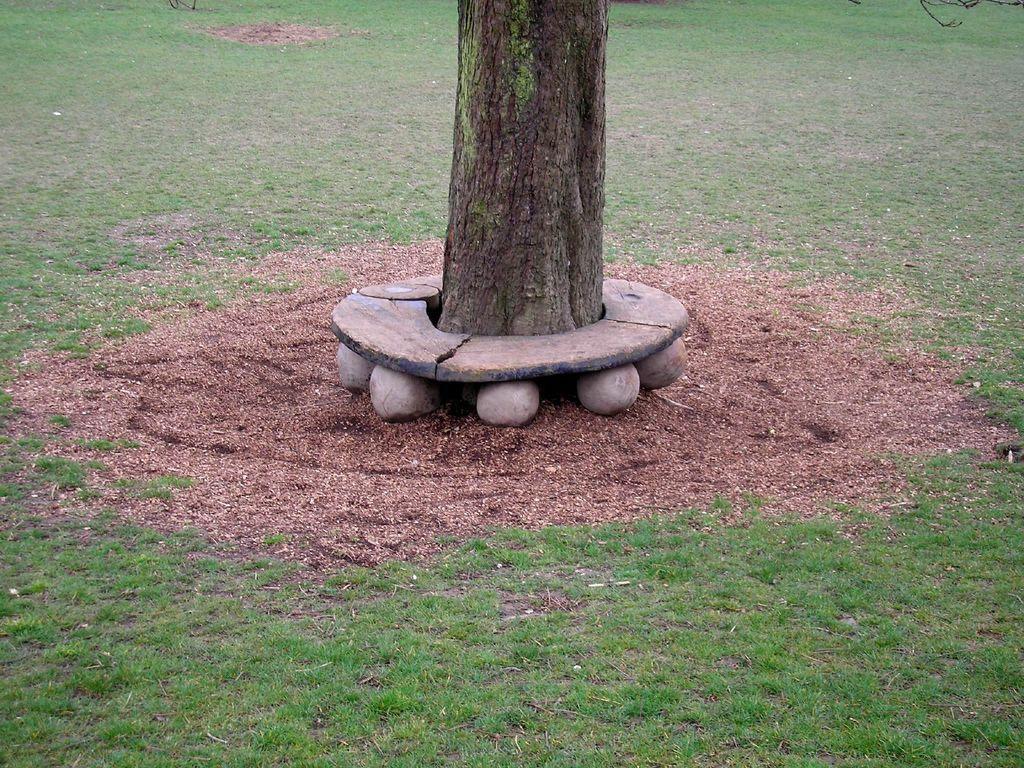Can you describe this image briefly? In this image I can see an open grass ground and in the centre I can see few stones and a tree trunk. 